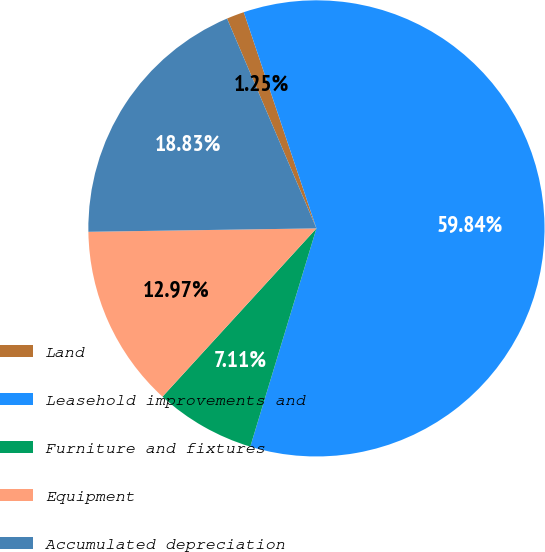Convert chart. <chart><loc_0><loc_0><loc_500><loc_500><pie_chart><fcel>Land<fcel>Leasehold improvements and<fcel>Furniture and fixtures<fcel>Equipment<fcel>Accumulated depreciation<nl><fcel>1.25%<fcel>59.85%<fcel>7.11%<fcel>12.97%<fcel>18.83%<nl></chart> 